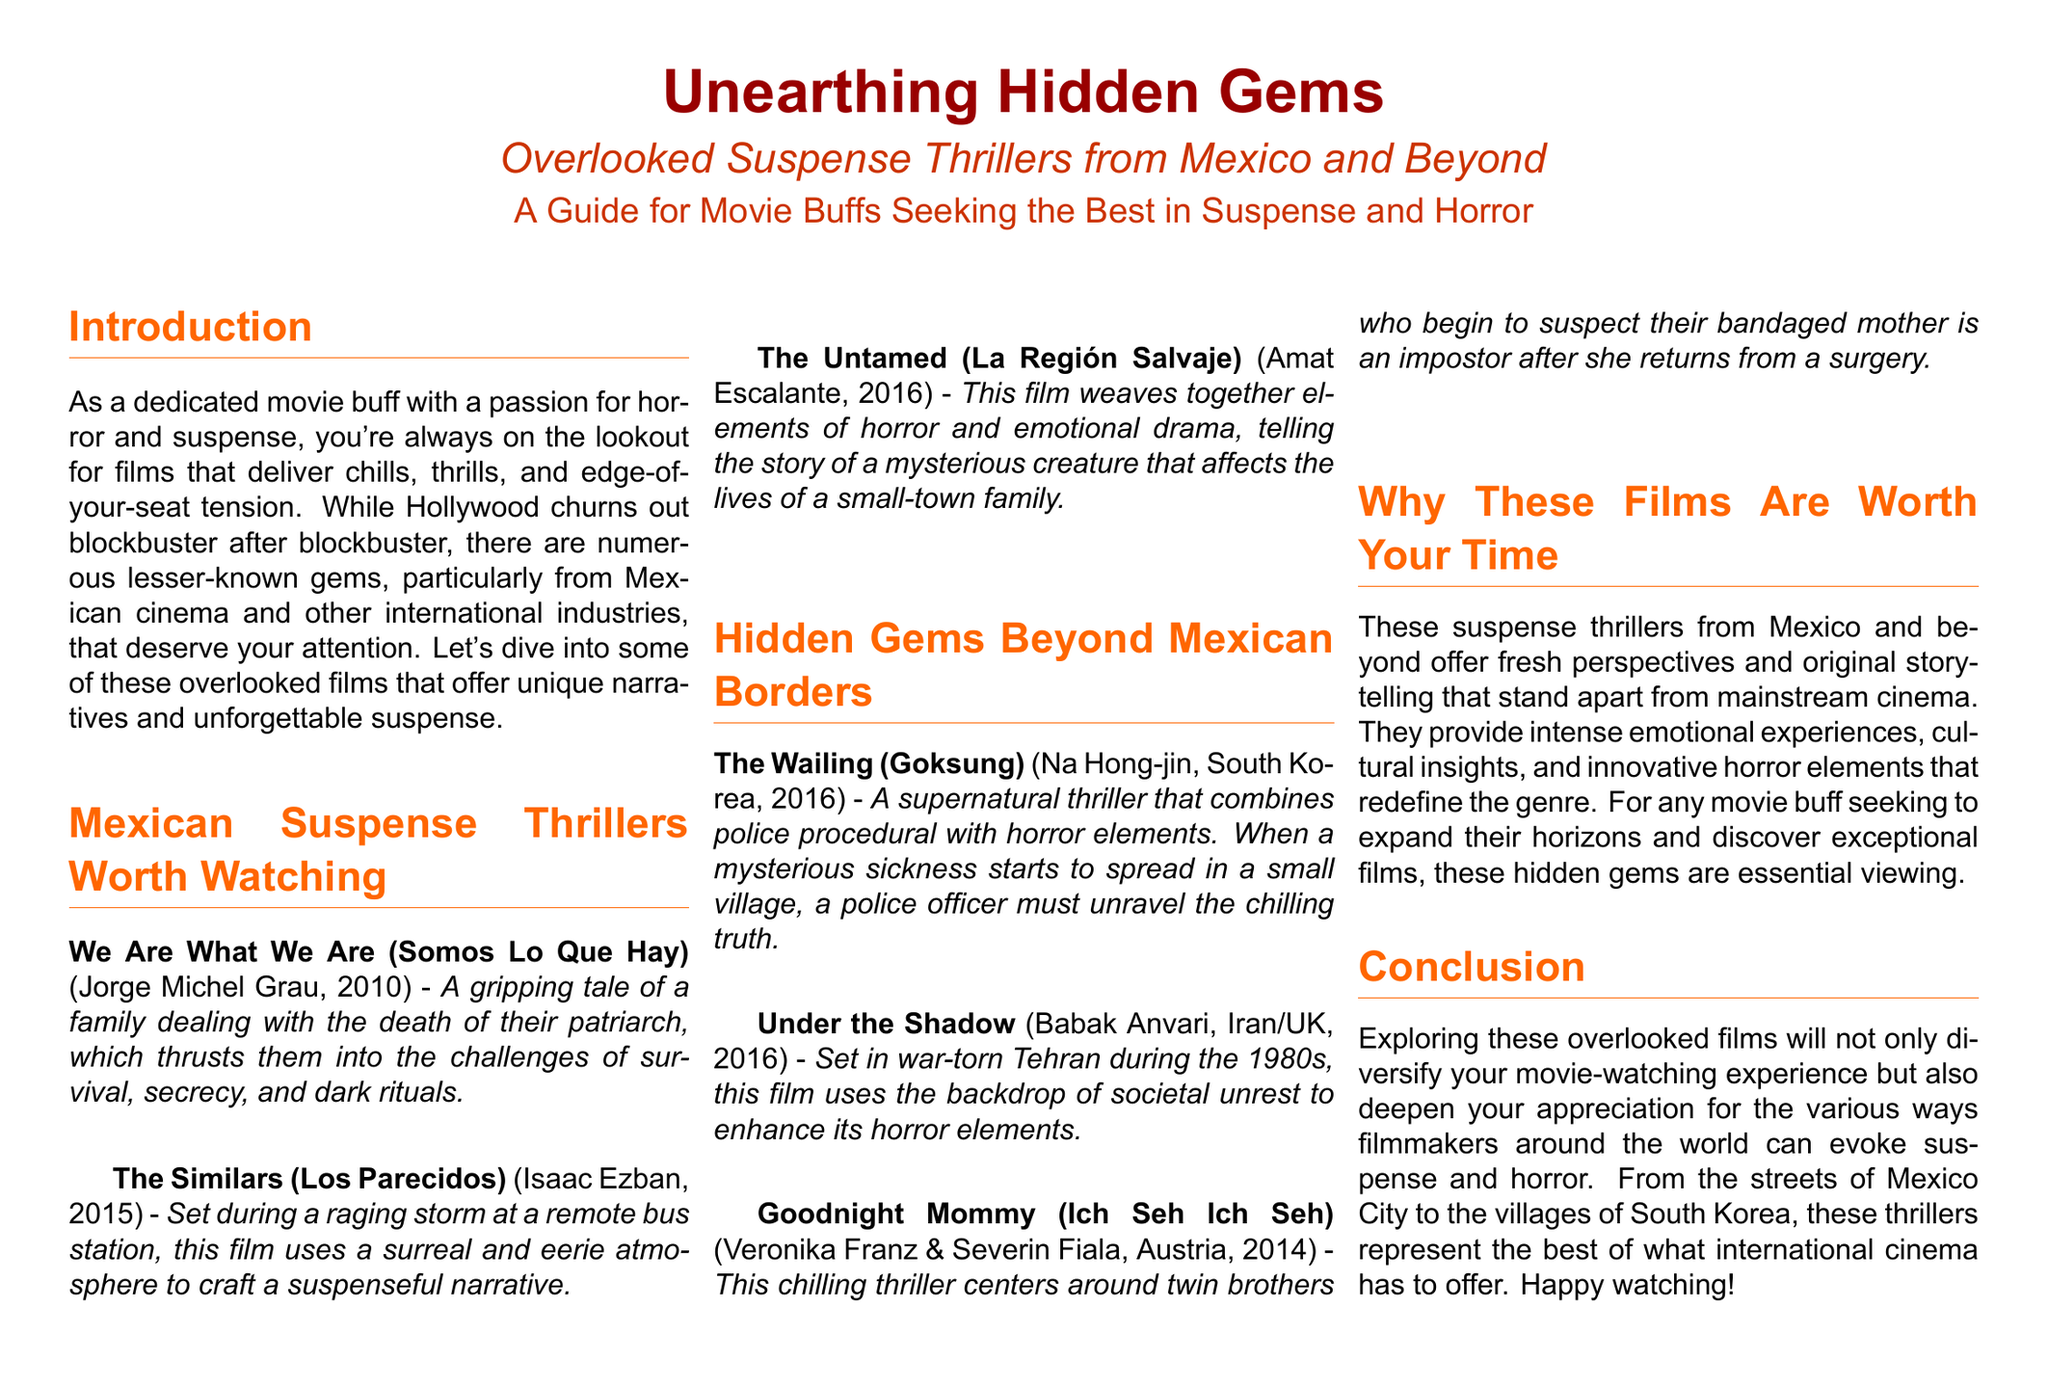What year was "We Are What We Are" released? The document lists the release year of the film "We Are What We Are" as 2010.
Answer: 2010 Who directed "The Similars"? The document states that "The Similars" was directed by Isaac Ezban.
Answer: Isaac Ezban What genre is "The Wailing"? The document categorizes "The Wailing" as a supernatural thriller.
Answer: supernatural thriller How many films are listed under "Mexican Suspense Thrillers Worth Watching"? The section contains a total of three films listed.
Answer: three Which film features twin brothers? The document mentions "Goodnight Mommy" as the film that centers around twin brothers.
Answer: Goodnight Mommy What cultural setting enhances the horror in "Under the Shadow"? The document notes that "Under the Shadow" is set in war-torn Tehran during the 1980s.
Answer: war-torn Tehran Why are these suspense thrillers considered worth watching? The document explains that these thrillers provide fresh perspectives and original storytelling that stand apart from mainstream cinema.
Answer: fresh perspectives and original storytelling What is the purpose of this magazine layout? The document aims to guide movie buffs seeking the best in suspense and horror.
Answer: guide for movie buffs What is the subtitle of the document? The subtitle provided in the document is "Overlooked Suspense Thrillers from Mexico and Beyond."
Answer: Overlooked Suspense Thrillers from Mexico and Beyond 